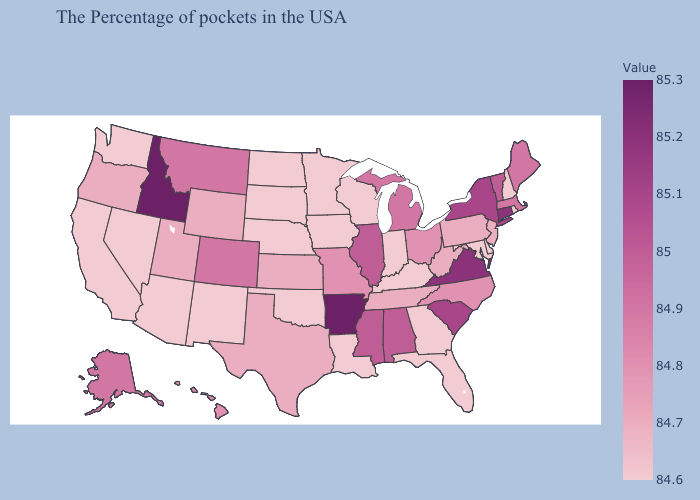Does Oregon have the lowest value in the USA?
Concise answer only. No. Among the states that border Maryland , which have the highest value?
Quick response, please. Virginia. Does Kansas have the highest value in the USA?
Concise answer only. No. Does Connecticut have a lower value than Arkansas?
Short answer required. Yes. 